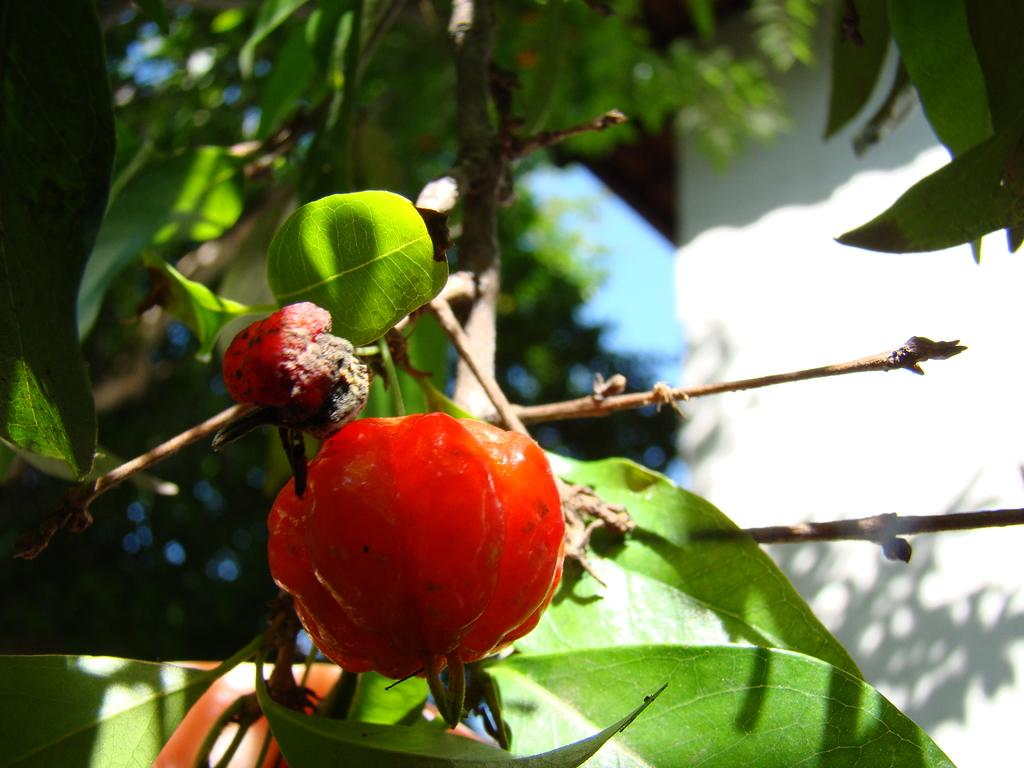What type of fruit is in the image? There is an orange-colored fruit in the image. Where is the fruit located in the image? The fruit is in the middle of the image. What can be seen in the background of the image? There are stems with green leaves in the background of the image. What is on the right side of the image? There is a wall on the right side of the image. What type of trousers can be seen hanging on the wall in the image? There are no trousers present in the image; it only features an orange-colored fruit, stems with green leaves, and a wall. 